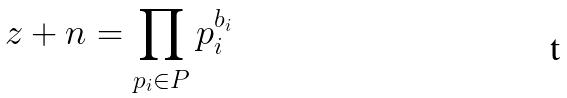Convert formula to latex. <formula><loc_0><loc_0><loc_500><loc_500>z + n = \prod _ { p _ { i } \in P } p _ { i } ^ { b _ { i } }</formula> 